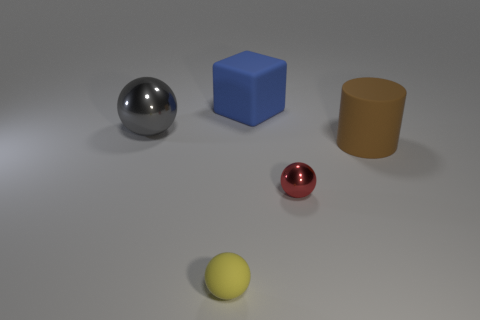Is there any other thing that is the same shape as the big brown object?
Your response must be concise. No. The small yellow matte object is what shape?
Provide a short and direct response. Sphere. There is a large matte object that is behind the brown rubber object; does it have the same color as the matte sphere?
Provide a succinct answer. No. The red metal thing that is the same shape as the small yellow thing is what size?
Keep it short and to the point. Small. Is there anything else that has the same material as the large brown cylinder?
Provide a short and direct response. Yes. There is a blue cube behind the shiny thing that is in front of the brown matte thing; are there any big metal balls that are in front of it?
Your answer should be compact. Yes. There is a ball that is on the right side of the blue block; what is its material?
Keep it short and to the point. Metal. What number of tiny things are blue objects or yellow rubber spheres?
Keep it short and to the point. 1. There is a metallic ball that is in front of the gray object; is it the same size as the rubber cylinder?
Offer a terse response. No. How many other things are the same color as the small rubber thing?
Your response must be concise. 0. 